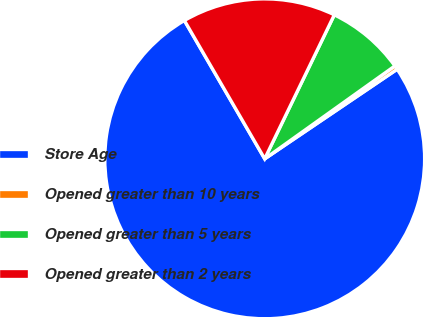Convert chart. <chart><loc_0><loc_0><loc_500><loc_500><pie_chart><fcel>Store Age<fcel>Opened greater than 10 years<fcel>Opened greater than 5 years<fcel>Opened greater than 2 years<nl><fcel>76.1%<fcel>0.4%<fcel>7.97%<fcel>15.54%<nl></chart> 